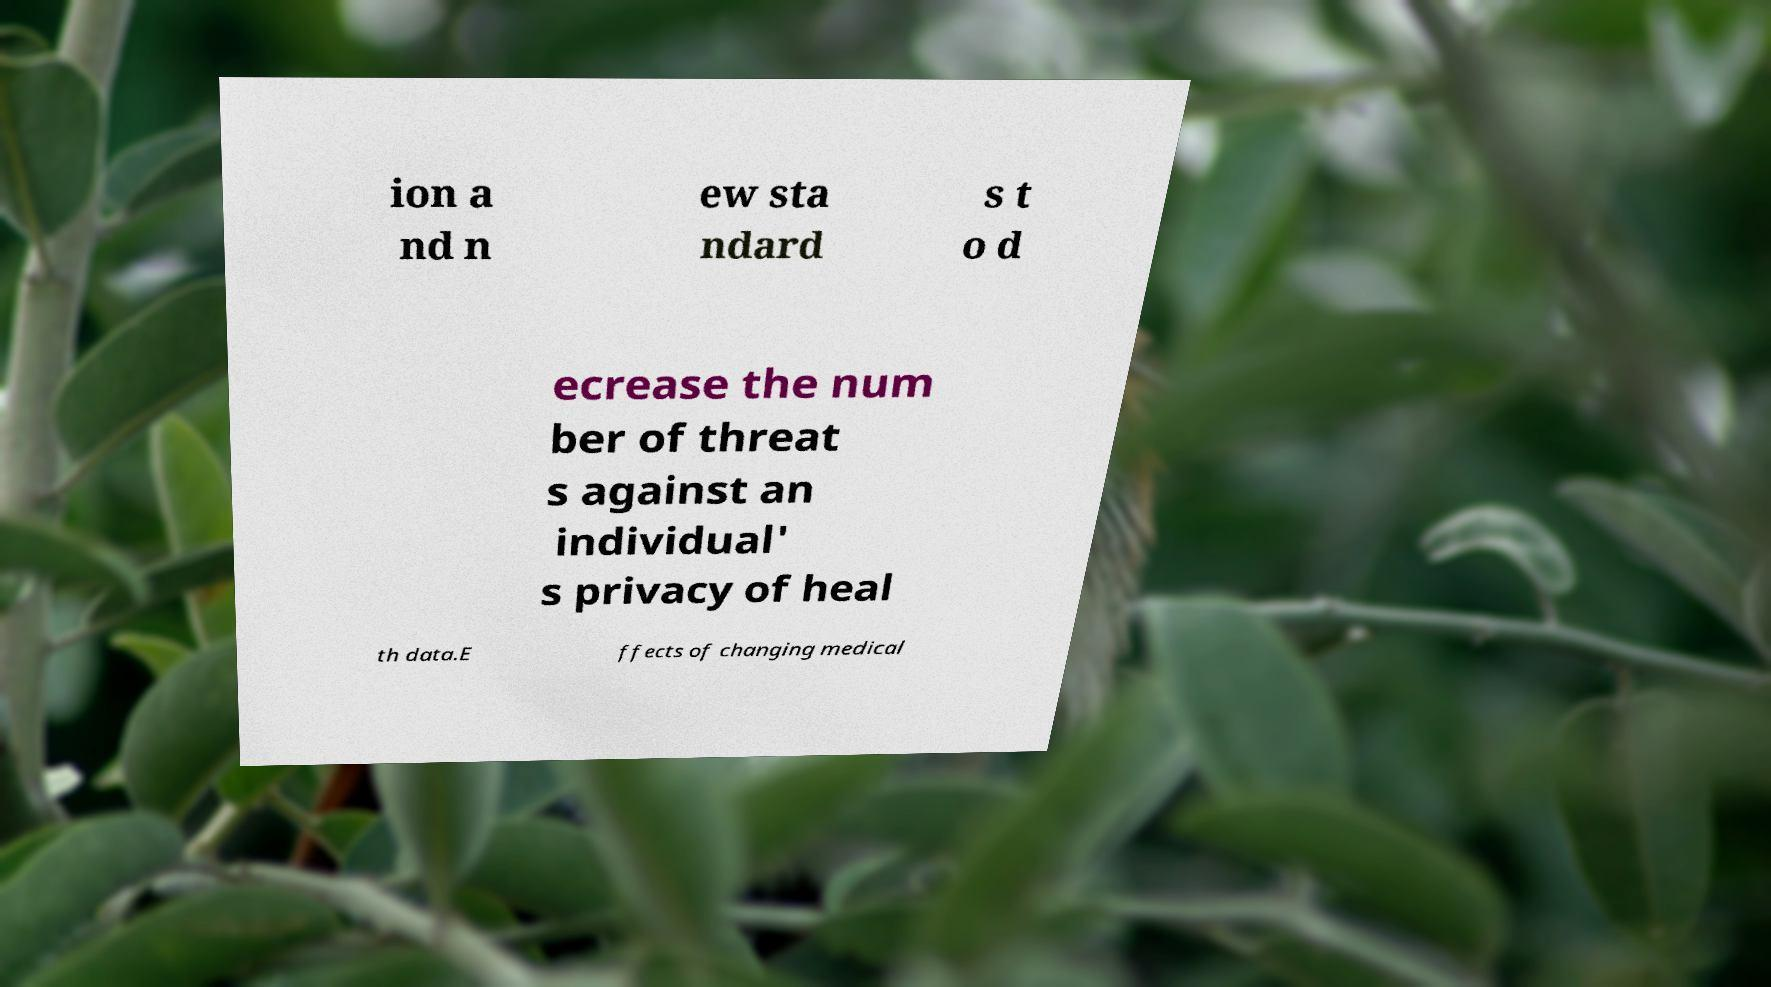For documentation purposes, I need the text within this image transcribed. Could you provide that? ion a nd n ew sta ndard s t o d ecrease the num ber of threat s against an individual' s privacy of heal th data.E ffects of changing medical 